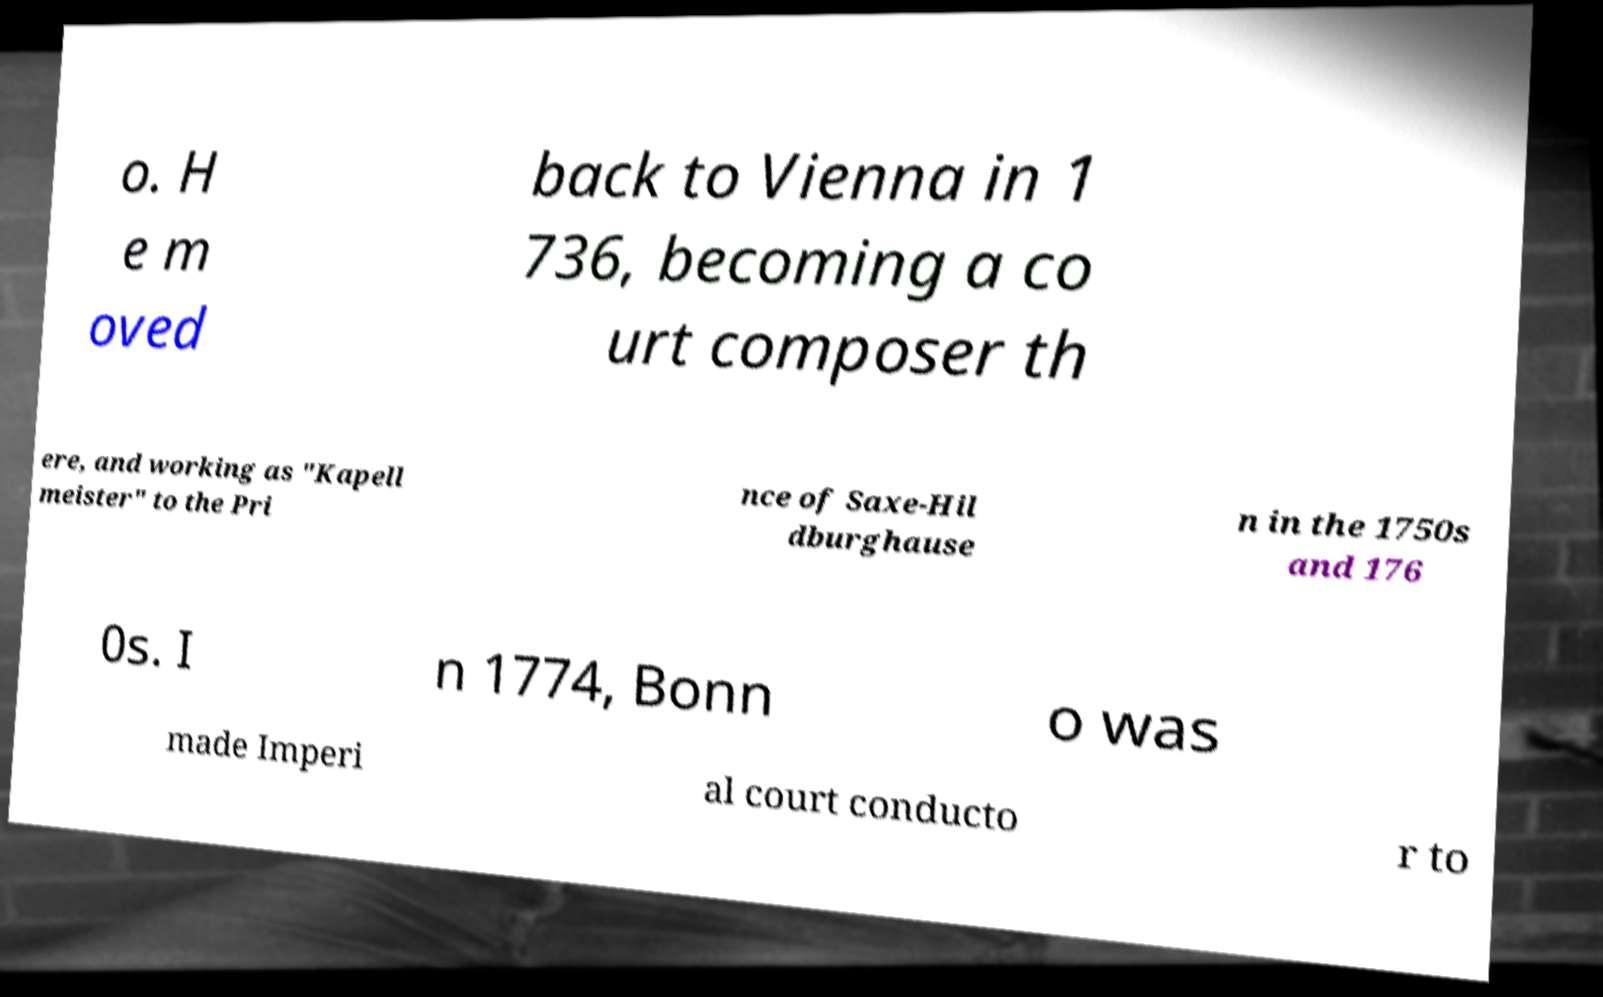Could you extract and type out the text from this image? o. H e m oved back to Vienna in 1 736, becoming a co urt composer th ere, and working as "Kapell meister" to the Pri nce of Saxe-Hil dburghause n in the 1750s and 176 0s. I n 1774, Bonn o was made Imperi al court conducto r to 